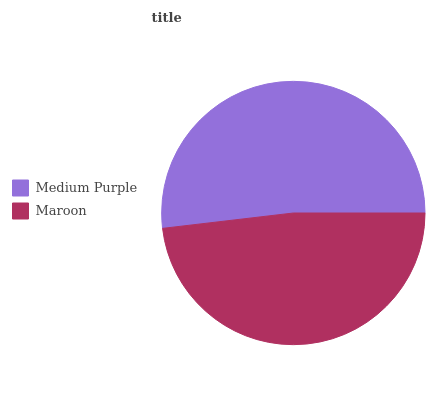Is Maroon the minimum?
Answer yes or no. Yes. Is Medium Purple the maximum?
Answer yes or no. Yes. Is Maroon the maximum?
Answer yes or no. No. Is Medium Purple greater than Maroon?
Answer yes or no. Yes. Is Maroon less than Medium Purple?
Answer yes or no. Yes. Is Maroon greater than Medium Purple?
Answer yes or no. No. Is Medium Purple less than Maroon?
Answer yes or no. No. Is Medium Purple the high median?
Answer yes or no. Yes. Is Maroon the low median?
Answer yes or no. Yes. Is Maroon the high median?
Answer yes or no. No. Is Medium Purple the low median?
Answer yes or no. No. 